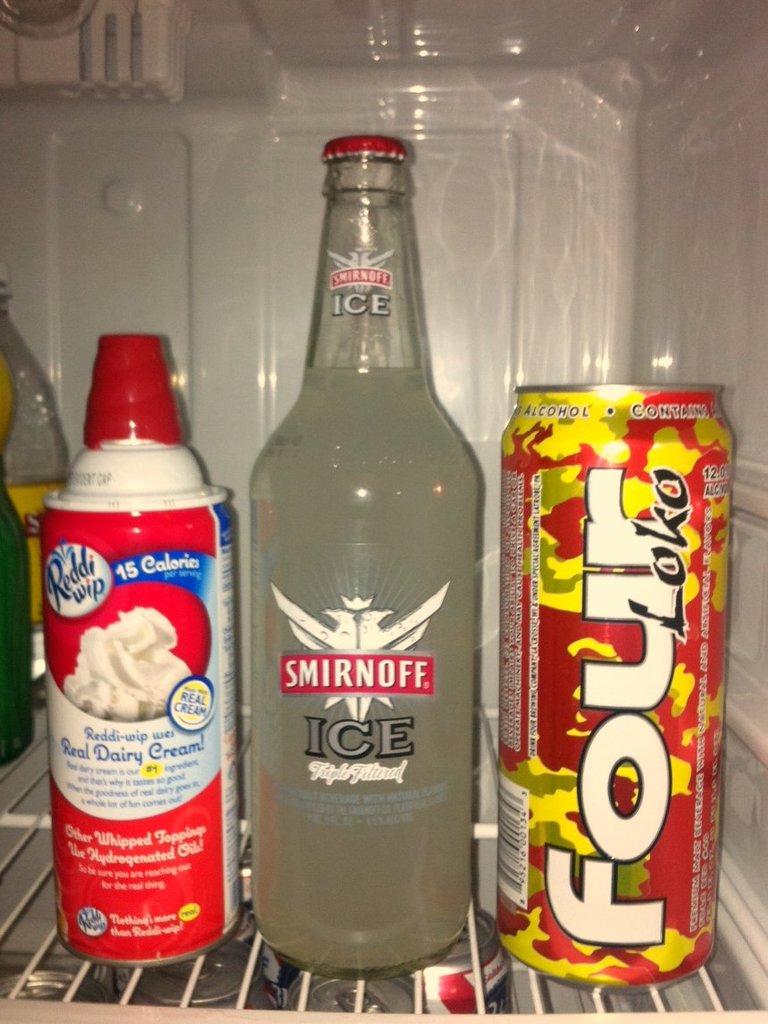What brand drink is in the bottle?
Your answer should be very brief. Smirnoff. 